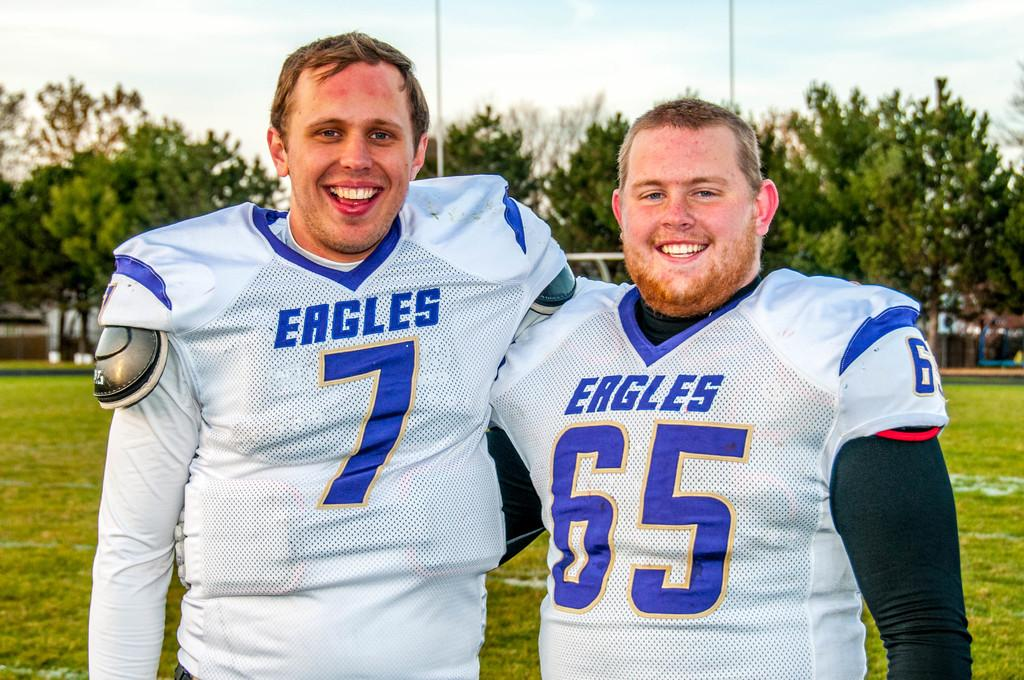<image>
Describe the image concisely. Two men in Eagles uniforms posing for a picture. 